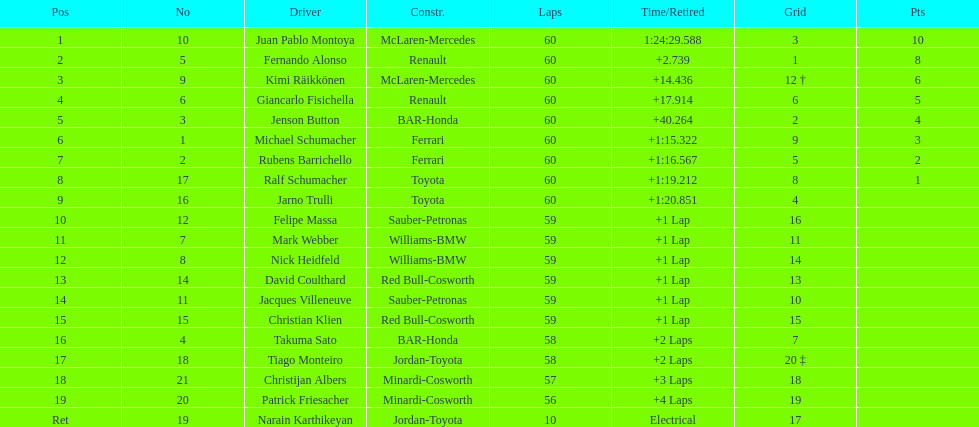How many drivers received points from the race? 8. Parse the full table. {'header': ['Pos', 'No', 'Driver', 'Constr.', 'Laps', 'Time/Retired', 'Grid', 'Pts'], 'rows': [['1', '10', 'Juan Pablo Montoya', 'McLaren-Mercedes', '60', '1:24:29.588', '3', '10'], ['2', '5', 'Fernando Alonso', 'Renault', '60', '+2.739', '1', '8'], ['3', '9', 'Kimi Räikkönen', 'McLaren-Mercedes', '60', '+14.436', '12 †', '6'], ['4', '6', 'Giancarlo Fisichella', 'Renault', '60', '+17.914', '6', '5'], ['5', '3', 'Jenson Button', 'BAR-Honda', '60', '+40.264', '2', '4'], ['6', '1', 'Michael Schumacher', 'Ferrari', '60', '+1:15.322', '9', '3'], ['7', '2', 'Rubens Barrichello', 'Ferrari', '60', '+1:16.567', '5', '2'], ['8', '17', 'Ralf Schumacher', 'Toyota', '60', '+1:19.212', '8', '1'], ['9', '16', 'Jarno Trulli', 'Toyota', '60', '+1:20.851', '4', ''], ['10', '12', 'Felipe Massa', 'Sauber-Petronas', '59', '+1 Lap', '16', ''], ['11', '7', 'Mark Webber', 'Williams-BMW', '59', '+1 Lap', '11', ''], ['12', '8', 'Nick Heidfeld', 'Williams-BMW', '59', '+1 Lap', '14', ''], ['13', '14', 'David Coulthard', 'Red Bull-Cosworth', '59', '+1 Lap', '13', ''], ['14', '11', 'Jacques Villeneuve', 'Sauber-Petronas', '59', '+1 Lap', '10', ''], ['15', '15', 'Christian Klien', 'Red Bull-Cosworth', '59', '+1 Lap', '15', ''], ['16', '4', 'Takuma Sato', 'BAR-Honda', '58', '+2 Laps', '7', ''], ['17', '18', 'Tiago Monteiro', 'Jordan-Toyota', '58', '+2 Laps', '20 ‡', ''], ['18', '21', 'Christijan Albers', 'Minardi-Cosworth', '57', '+3 Laps', '18', ''], ['19', '20', 'Patrick Friesacher', 'Minardi-Cosworth', '56', '+4 Laps', '19', ''], ['Ret', '19', 'Narain Karthikeyan', 'Jordan-Toyota', '10', 'Electrical', '17', '']]} 